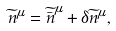Convert formula to latex. <formula><loc_0><loc_0><loc_500><loc_500>\widetilde { n } ^ { \mu } = \widetilde { \bar { n } } ^ { \mu } + \delta \widetilde { n } ^ { \mu } ,</formula> 